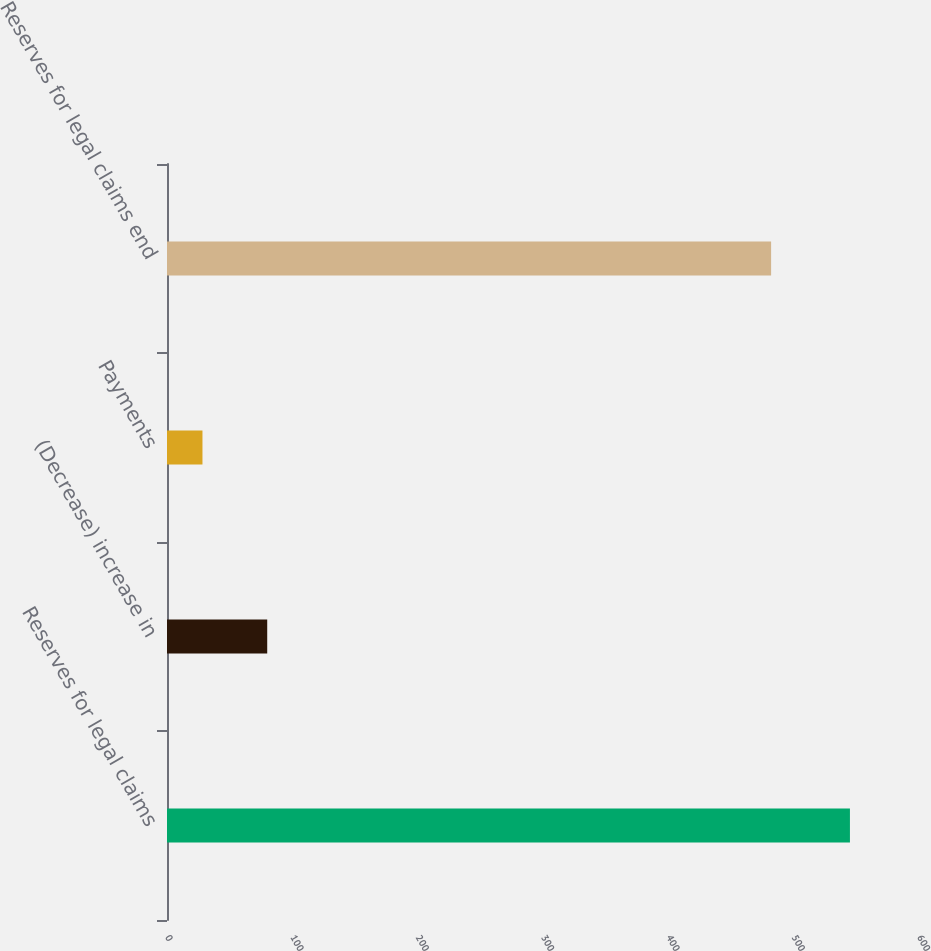<chart> <loc_0><loc_0><loc_500><loc_500><bar_chart><fcel>Reserves for legal claims<fcel>(Decrease) increase in<fcel>Payments<fcel>Reserves for legal claims end<nl><fcel>544.9<fcel>79.96<fcel>28.3<fcel>482<nl></chart> 